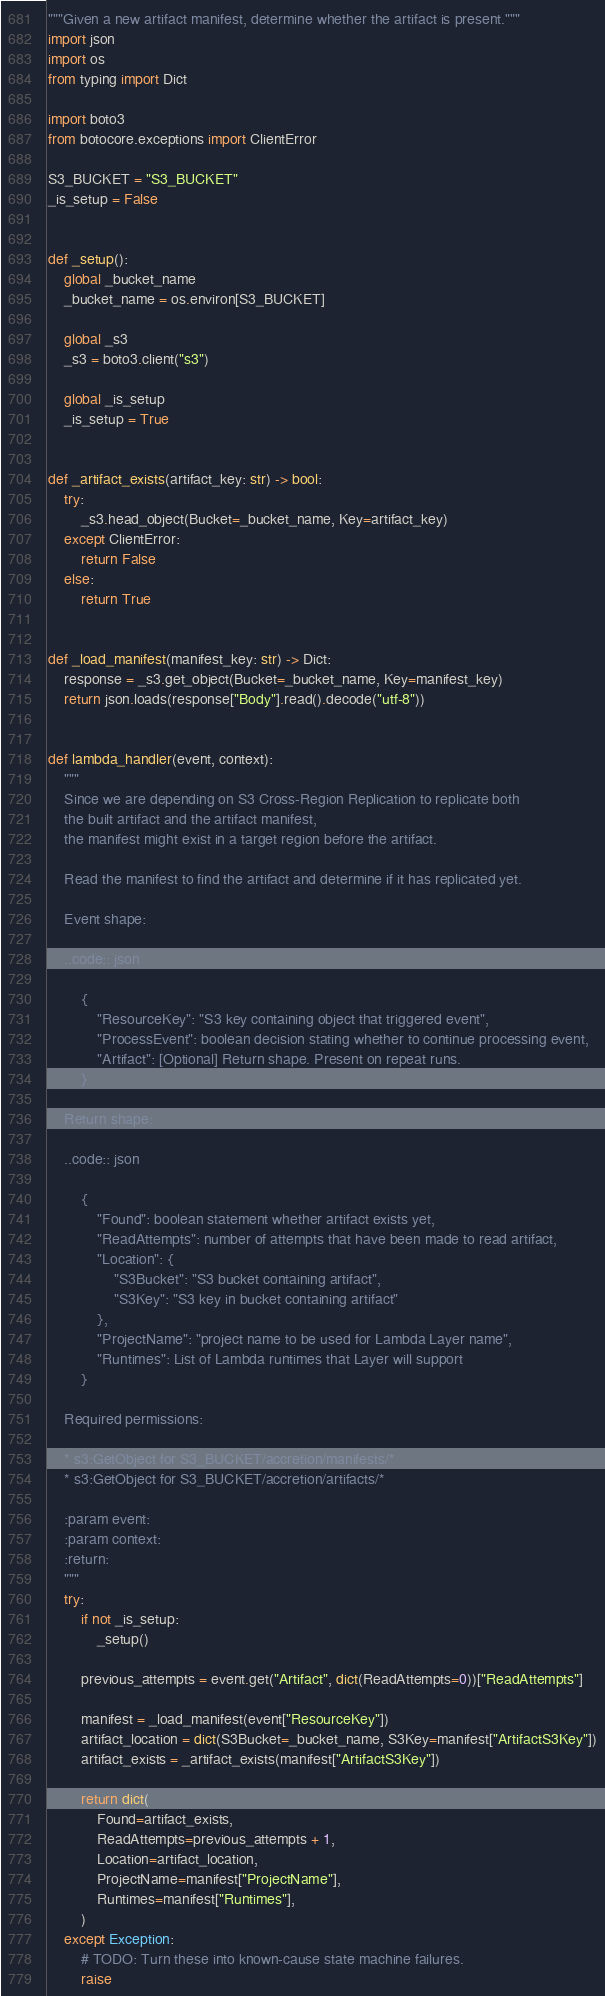Convert code to text. <code><loc_0><loc_0><loc_500><loc_500><_Python_>"""Given a new artifact manifest, determine whether the artifact is present."""
import json
import os
from typing import Dict

import boto3
from botocore.exceptions import ClientError

S3_BUCKET = "S3_BUCKET"
_is_setup = False


def _setup():
    global _bucket_name
    _bucket_name = os.environ[S3_BUCKET]

    global _s3
    _s3 = boto3.client("s3")

    global _is_setup
    _is_setup = True


def _artifact_exists(artifact_key: str) -> bool:
    try:
        _s3.head_object(Bucket=_bucket_name, Key=artifact_key)
    except ClientError:
        return False
    else:
        return True


def _load_manifest(manifest_key: str) -> Dict:
    response = _s3.get_object(Bucket=_bucket_name, Key=manifest_key)
    return json.loads(response["Body"].read().decode("utf-8"))


def lambda_handler(event, context):
    """
    Since we are depending on S3 Cross-Region Replication to replicate both
    the built artifact and the artifact manifest,
    the manifest might exist in a target region before the artifact.

    Read the manifest to find the artifact and determine if it has replicated yet.

    Event shape:

    ..code:: json

        {
            "ResourceKey": "S3 key containing object that triggered event",
            "ProcessEvent": boolean decision stating whether to continue processing event,
            "Artifact": [Optional] Return shape. Present on repeat runs.
        }

    Return shape:

    ..code:: json

        {
            "Found": boolean statement whether artifact exists yet,
            "ReadAttempts": number of attempts that have been made to read artifact,
            "Location": {
                "S3Bucket": "S3 bucket containing artifact",
                "S3Key": "S3 key in bucket containing artifact"
            },
            "ProjectName": "project name to be used for Lambda Layer name",
            "Runtimes": List of Lambda runtimes that Layer will support
        }

    Required permissions:

    * s3:GetObject for S3_BUCKET/accretion/manifests/*
    * s3:GetObject for S3_BUCKET/accretion/artifacts/*

    :param event:
    :param context:
    :return:
    """
    try:
        if not _is_setup:
            _setup()

        previous_attempts = event.get("Artifact", dict(ReadAttempts=0))["ReadAttempts"]

        manifest = _load_manifest(event["ResourceKey"])
        artifact_location = dict(S3Bucket=_bucket_name, S3Key=manifest["ArtifactS3Key"])
        artifact_exists = _artifact_exists(manifest["ArtifactS3Key"])

        return dict(
            Found=artifact_exists,
            ReadAttempts=previous_attempts + 1,
            Location=artifact_location,
            ProjectName=manifest["ProjectName"],
            Runtimes=manifest["Runtimes"],
        )
    except Exception:
        # TODO: Turn these into known-cause state machine failures.
        raise
</code> 